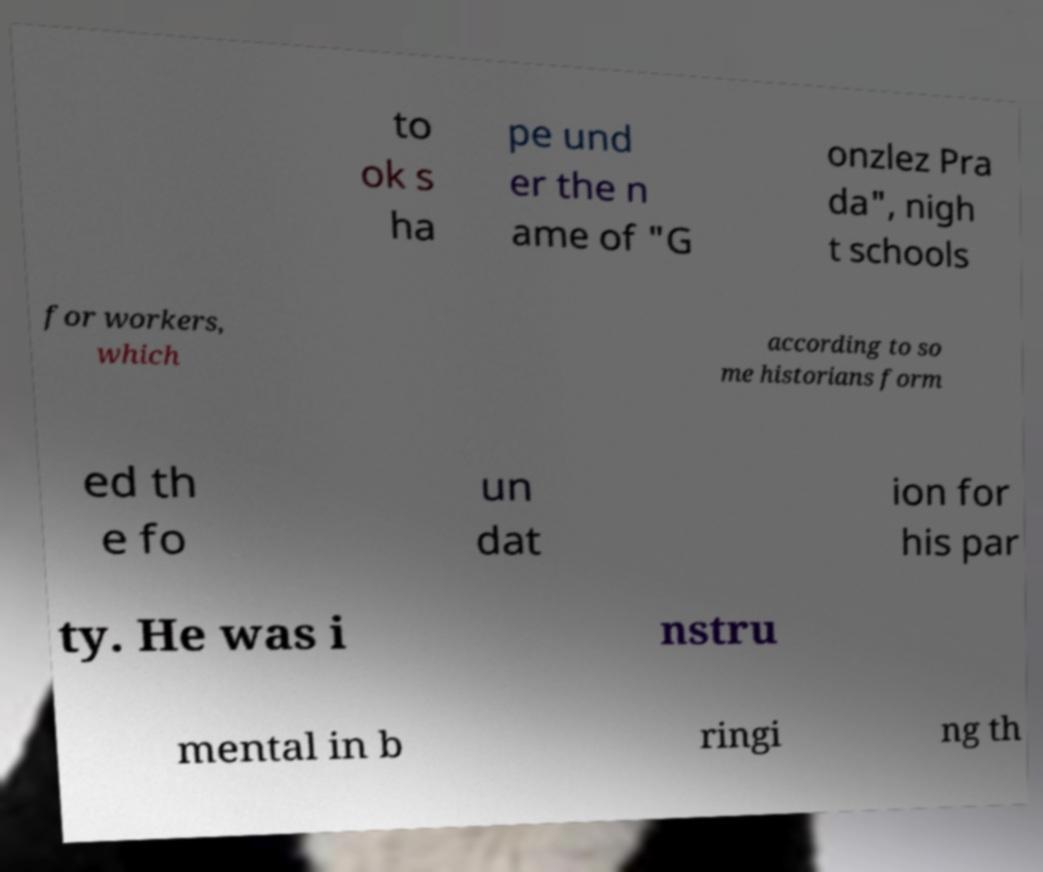What messages or text are displayed in this image? I need them in a readable, typed format. to ok s ha pe und er the n ame of "G onzlez Pra da", nigh t schools for workers, which according to so me historians form ed th e fo un dat ion for his par ty. He was i nstru mental in b ringi ng th 